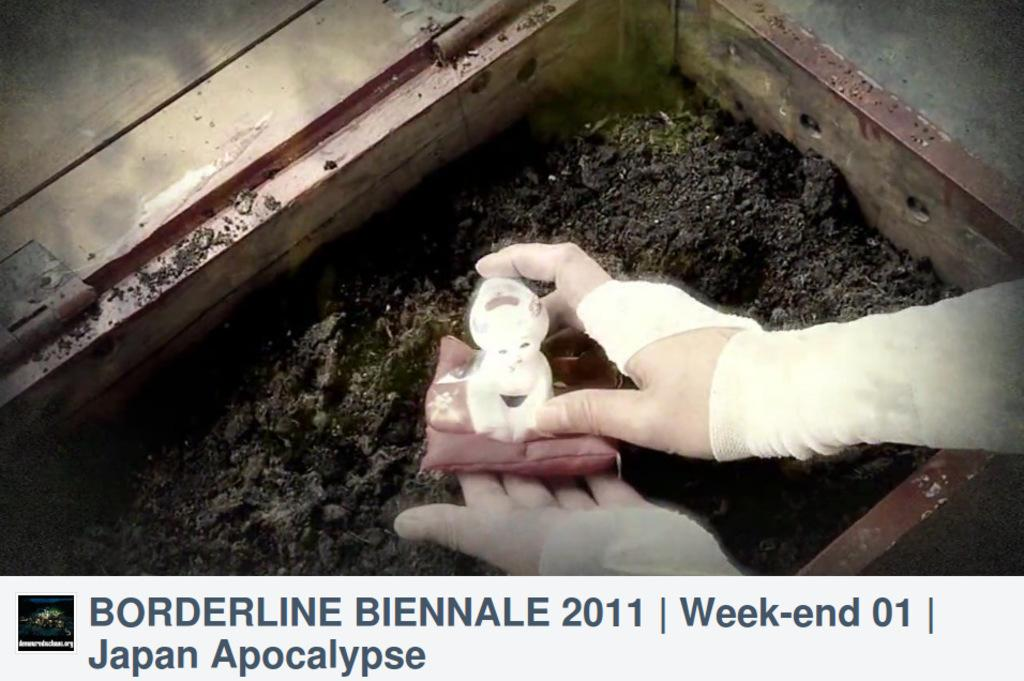What is the person holding in their hand in the image? There is a toy in the person's hand. What can be found in the wooden box in the image? There is soil in a wooden box. Can you read anything written at the bottom of the image? Unfortunately, the text at the bottom of the image is not legible in the provided facts. Can you see any ocean waves in the image? There is no ocean or waves present in the image. What type of winter clothing is the person wearing in the image? There is no person wearing winter clothing in the image; the facts only mention a toy in the person's hand. 